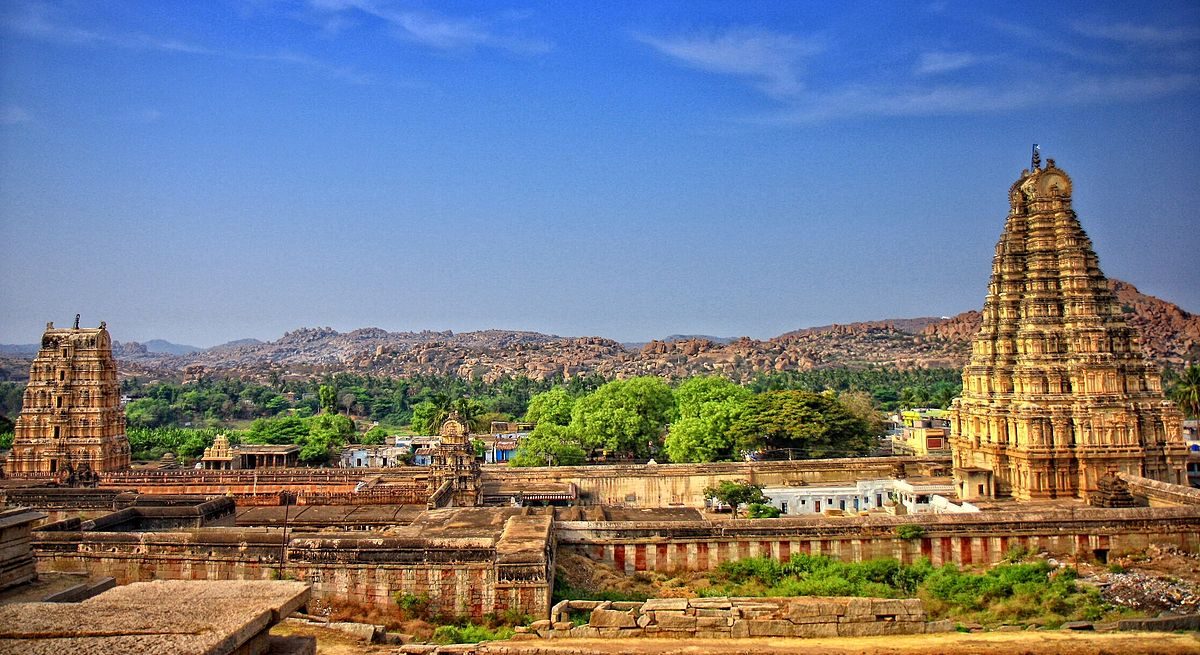Could you explain the significance of the architectural styles seen in this image? Certainly! The Virupaksha Temple is a stellar example of Dravidian architecture, characterized by its towering gopurams that dominate the entrance and the sanctum. These pyramidal towers are covered in a profusion of sculptures and carvings that depict deities, mythological scenes, and motifs from Hindu theology. The temple's layout follows a complex, axial design that includes a series of courtyards, pillared halls, and smaller shrines. These elements are not only aesthetically significant but also embody the religious and cultural ethos of their times, serving both ceremonial and practical purposes in the daily spiritual practices at the temple. 